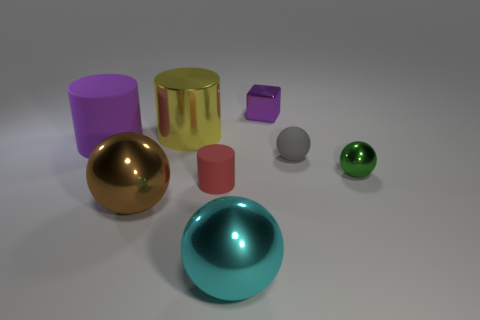What number of objects are behind the big brown metallic thing and in front of the small green ball?
Provide a succinct answer. 1. There is a purple object that is the same size as the yellow cylinder; what is its shape?
Make the answer very short. Cylinder. Are there any objects that are behind the large object in front of the sphere that is left of the tiny red object?
Provide a short and direct response. Yes. Do the large matte cylinder and the tiny object that is behind the large matte cylinder have the same color?
Ensure brevity in your answer.  Yes. What number of rubber things are the same color as the small cube?
Provide a short and direct response. 1. There is a shiny ball that is to the right of the big ball that is in front of the big brown thing; how big is it?
Provide a short and direct response. Small. What number of things are either matte things that are behind the small gray rubber object or purple metallic cubes?
Give a very brief answer. 2. Is there a rubber sphere of the same size as the purple cylinder?
Your response must be concise. No. Are there any yellow things on the left side of the big metallic object that is behind the tiny gray object?
Provide a short and direct response. No. How many cylinders are small things or small metal things?
Offer a terse response. 1. 